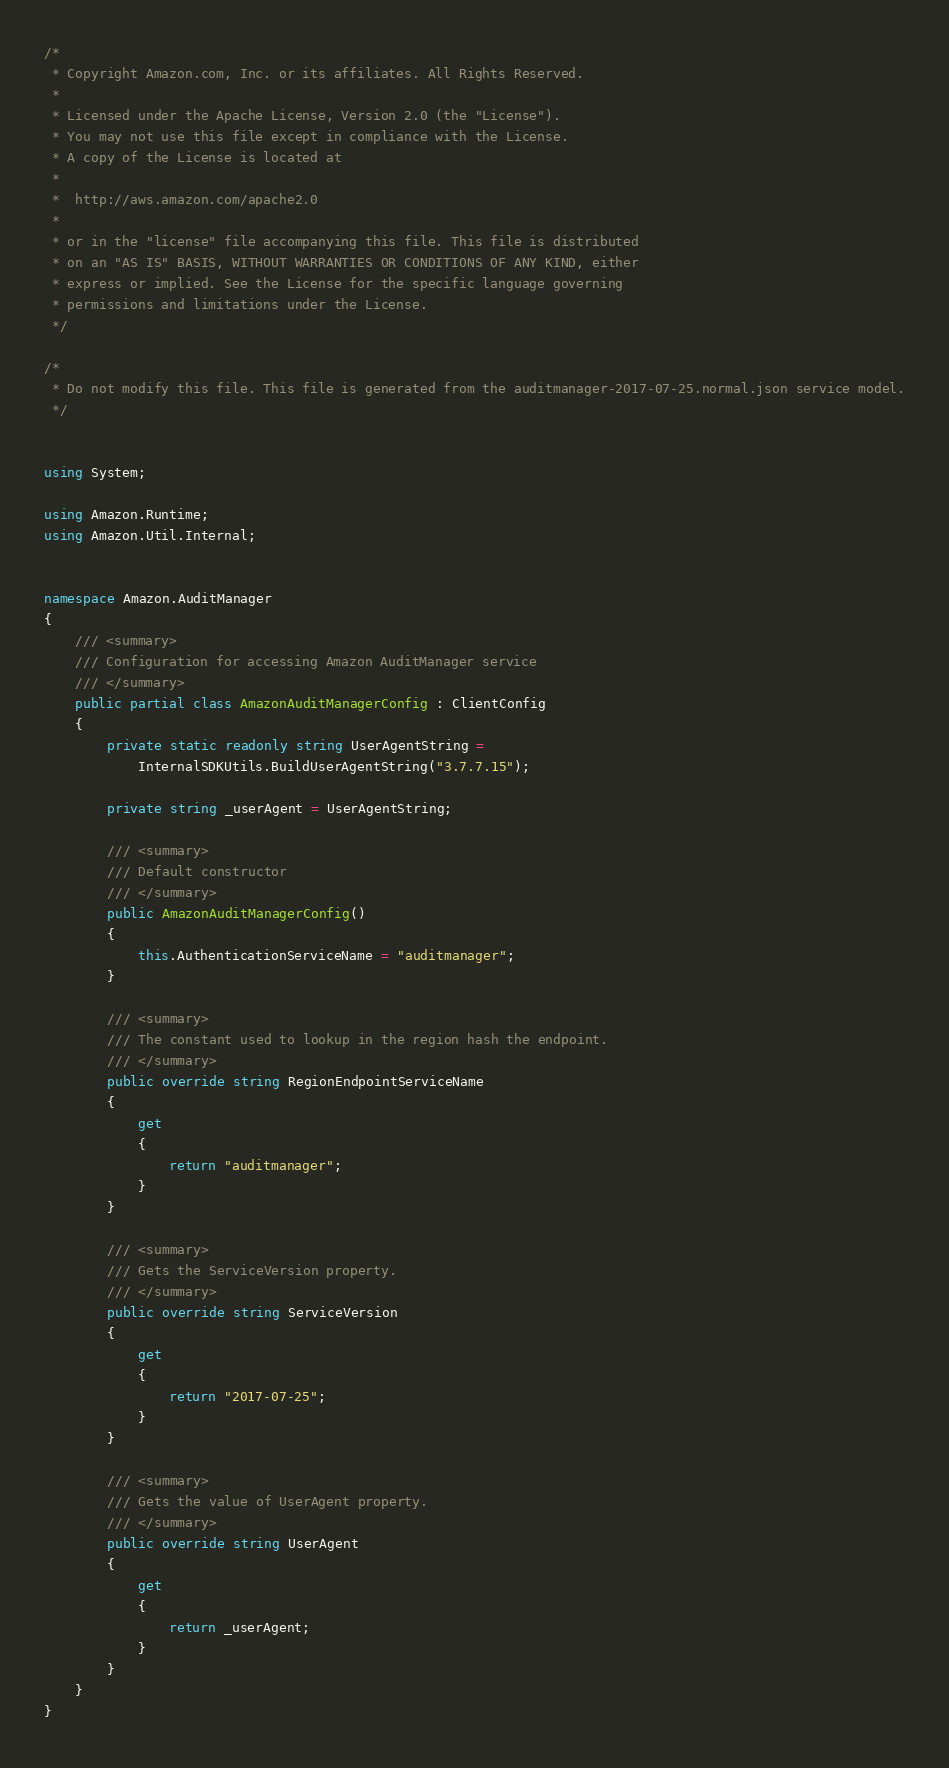Convert code to text. <code><loc_0><loc_0><loc_500><loc_500><_C#_>/*
 * Copyright Amazon.com, Inc. or its affiliates. All Rights Reserved.
 * 
 * Licensed under the Apache License, Version 2.0 (the "License").
 * You may not use this file except in compliance with the License.
 * A copy of the License is located at
 * 
 *  http://aws.amazon.com/apache2.0
 * 
 * or in the "license" file accompanying this file. This file is distributed
 * on an "AS IS" BASIS, WITHOUT WARRANTIES OR CONDITIONS OF ANY KIND, either
 * express or implied. See the License for the specific language governing
 * permissions and limitations under the License.
 */

/*
 * Do not modify this file. This file is generated from the auditmanager-2017-07-25.normal.json service model.
 */


using System;

using Amazon.Runtime;
using Amazon.Util.Internal;


namespace Amazon.AuditManager
{
    /// <summary>
    /// Configuration for accessing Amazon AuditManager service
    /// </summary>
    public partial class AmazonAuditManagerConfig : ClientConfig
    {
        private static readonly string UserAgentString =
            InternalSDKUtils.BuildUserAgentString("3.7.7.15");

        private string _userAgent = UserAgentString;

        /// <summary>
        /// Default constructor
        /// </summary>
        public AmazonAuditManagerConfig()
        {
            this.AuthenticationServiceName = "auditmanager";
        }

        /// <summary>
        /// The constant used to lookup in the region hash the endpoint.
        /// </summary>
        public override string RegionEndpointServiceName
        {
            get
            {
                return "auditmanager";
            }
        }

        /// <summary>
        /// Gets the ServiceVersion property.
        /// </summary>
        public override string ServiceVersion
        {
            get
            {
                return "2017-07-25";
            }
        }

        /// <summary>
        /// Gets the value of UserAgent property.
        /// </summary>
        public override string UserAgent
        {
            get
            {
                return _userAgent;
            }
        }
    }
}</code> 